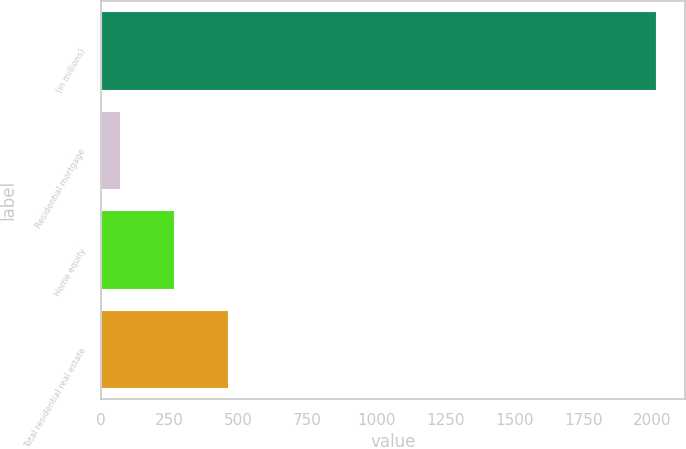Convert chart to OTSL. <chart><loc_0><loc_0><loc_500><loc_500><bar_chart><fcel>(in millions)<fcel>Residential mortgage<fcel>Home equity<fcel>Total residential real estate<nl><fcel>2017<fcel>75<fcel>269.2<fcel>463.4<nl></chart> 